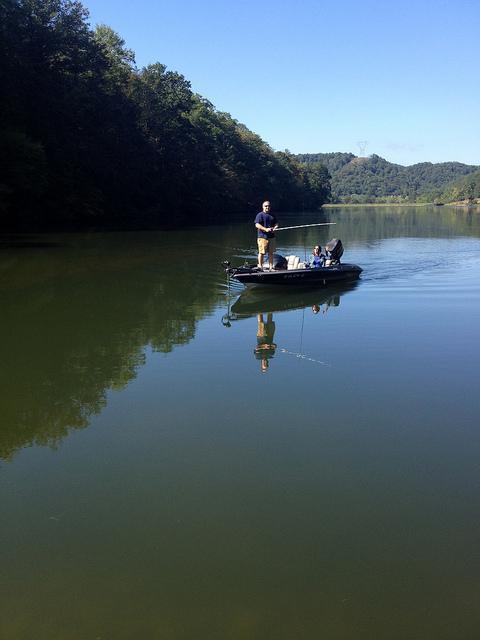How many people are sitting in the fishing boat on this day?
Make your selection and explain in format: 'Answer: answer
Rationale: rationale.'
Options: Three, four, two, one. Answer: two.
Rationale: There are two people fishing in the boat. 